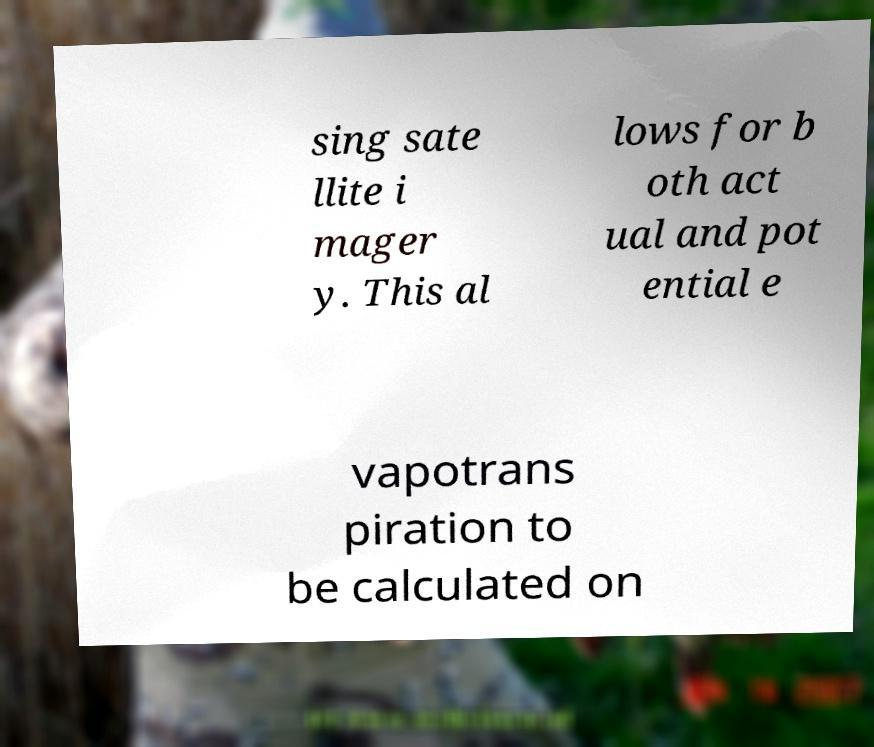For documentation purposes, I need the text within this image transcribed. Could you provide that? sing sate llite i mager y. This al lows for b oth act ual and pot ential e vapotrans piration to be calculated on 